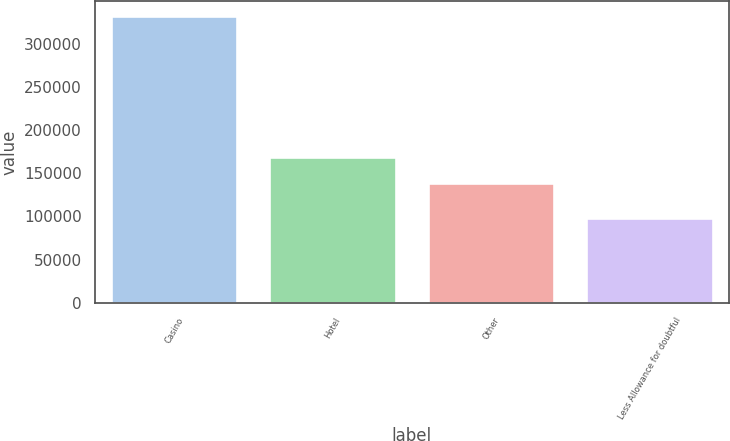<chart> <loc_0><loc_0><loc_500><loc_500><bar_chart><fcel>Casino<fcel>Hotel<fcel>Other<fcel>Less Allowance for doubtful<nl><fcel>332443<fcel>169321<fcel>139080<fcel>97920<nl></chart> 